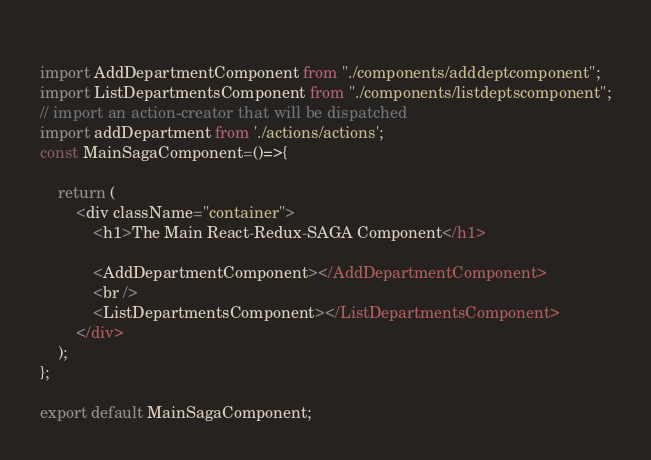Convert code to text. <code><loc_0><loc_0><loc_500><loc_500><_JavaScript_> 
import AddDepartmentComponent from "./components/adddeptcomponent";
import ListDepartmentsComponent from "./components/listdeptscomponent";
// import an action-creator that will be dispatched
import addDepartment from './actions/actions';
const MainSagaComponent=()=>{
   
    return (
        <div className="container">
            <h1>The Main React-Redux-SAGA Component</h1>
           
            <AddDepartmentComponent></AddDepartmentComponent>
            <br />
            <ListDepartmentsComponent></ListDepartmentsComponent>
        </div>
    );
};  

export default MainSagaComponent;</code> 